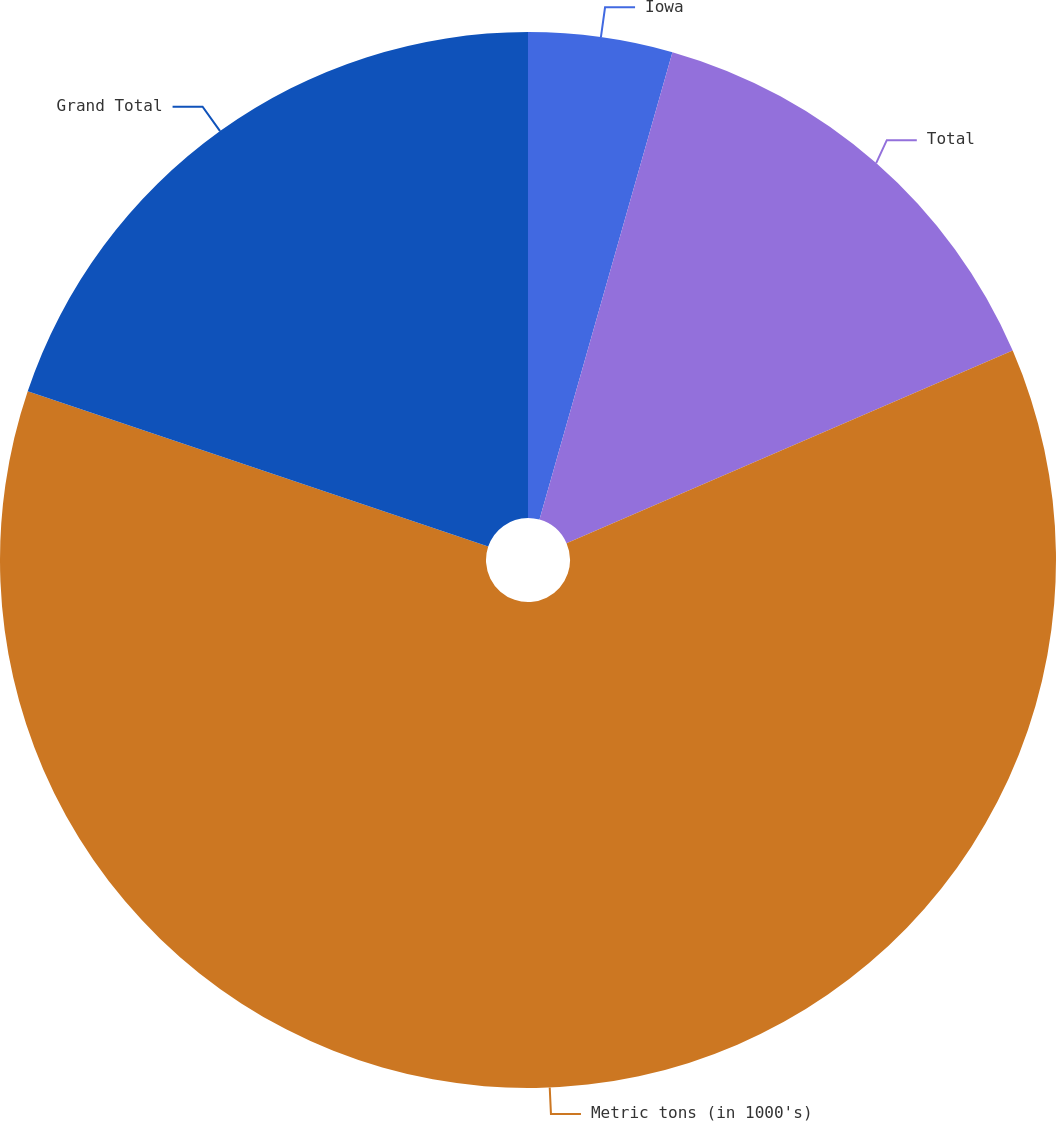Convert chart to OTSL. <chart><loc_0><loc_0><loc_500><loc_500><pie_chart><fcel>Iowa<fcel>Total<fcel>Metric tons (in 1000's)<fcel>Grand Total<nl><fcel>4.41%<fcel>14.1%<fcel>61.67%<fcel>19.82%<nl></chart> 